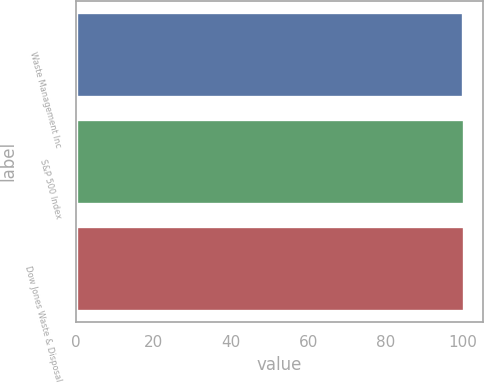Convert chart to OTSL. <chart><loc_0><loc_0><loc_500><loc_500><bar_chart><fcel>Waste Management Inc<fcel>S&P 500 Index<fcel>Dow Jones Waste & Disposal<nl><fcel>100<fcel>100.1<fcel>100.2<nl></chart> 